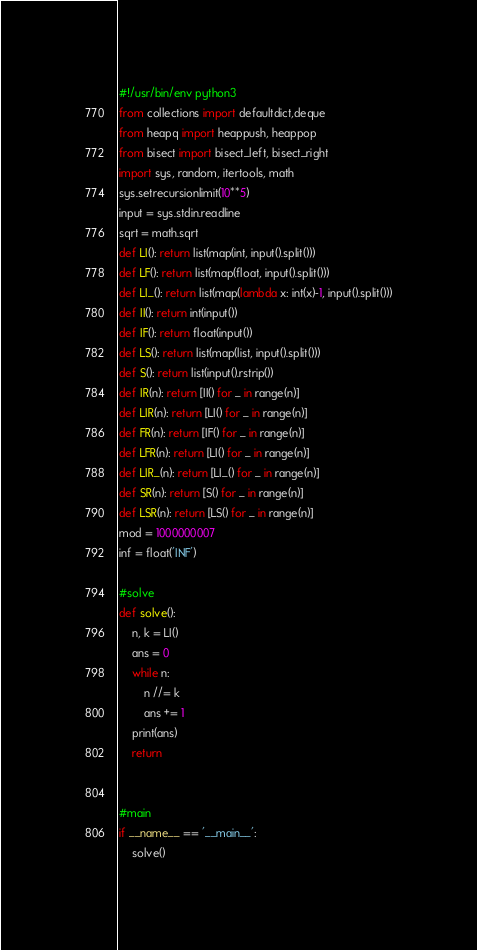<code> <loc_0><loc_0><loc_500><loc_500><_Python_>#!/usr/bin/env python3
from collections import defaultdict,deque
from heapq import heappush, heappop
from bisect import bisect_left, bisect_right
import sys, random, itertools, math
sys.setrecursionlimit(10**5)
input = sys.stdin.readline
sqrt = math.sqrt
def LI(): return list(map(int, input().split()))
def LF(): return list(map(float, input().split()))
def LI_(): return list(map(lambda x: int(x)-1, input().split()))
def II(): return int(input())
def IF(): return float(input())
def LS(): return list(map(list, input().split()))
def S(): return list(input().rstrip())
def IR(n): return [II() for _ in range(n)]
def LIR(n): return [LI() for _ in range(n)]
def FR(n): return [IF() for _ in range(n)]
def LFR(n): return [LI() for _ in range(n)]
def LIR_(n): return [LI_() for _ in range(n)]
def SR(n): return [S() for _ in range(n)]
def LSR(n): return [LS() for _ in range(n)]
mod = 1000000007
inf = float('INF')

#solve
def solve():
    n, k = LI()
    ans = 0
    while n:
        n //= k
        ans += 1
    print(ans)
    return


#main
if __name__ == '__main__':
    solve()
</code> 